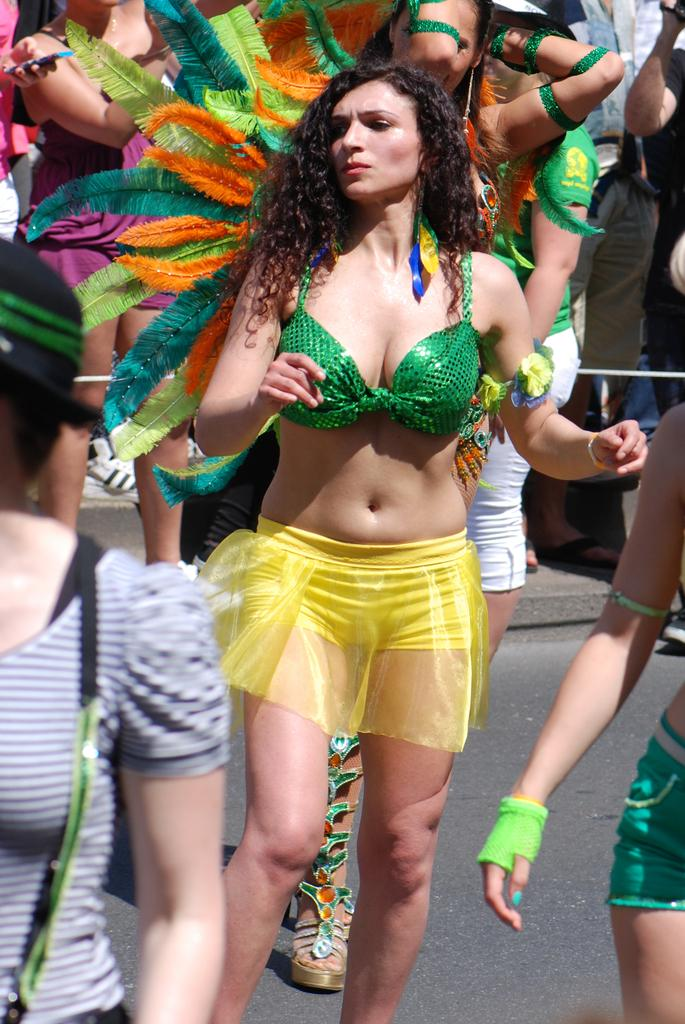Who is present in the image? There is a woman in the image. What can be seen behind the woman? There are different colored feathers behind the woman. What division is the woman working in the image? There is no indication of a division or workplace setting in the image. 